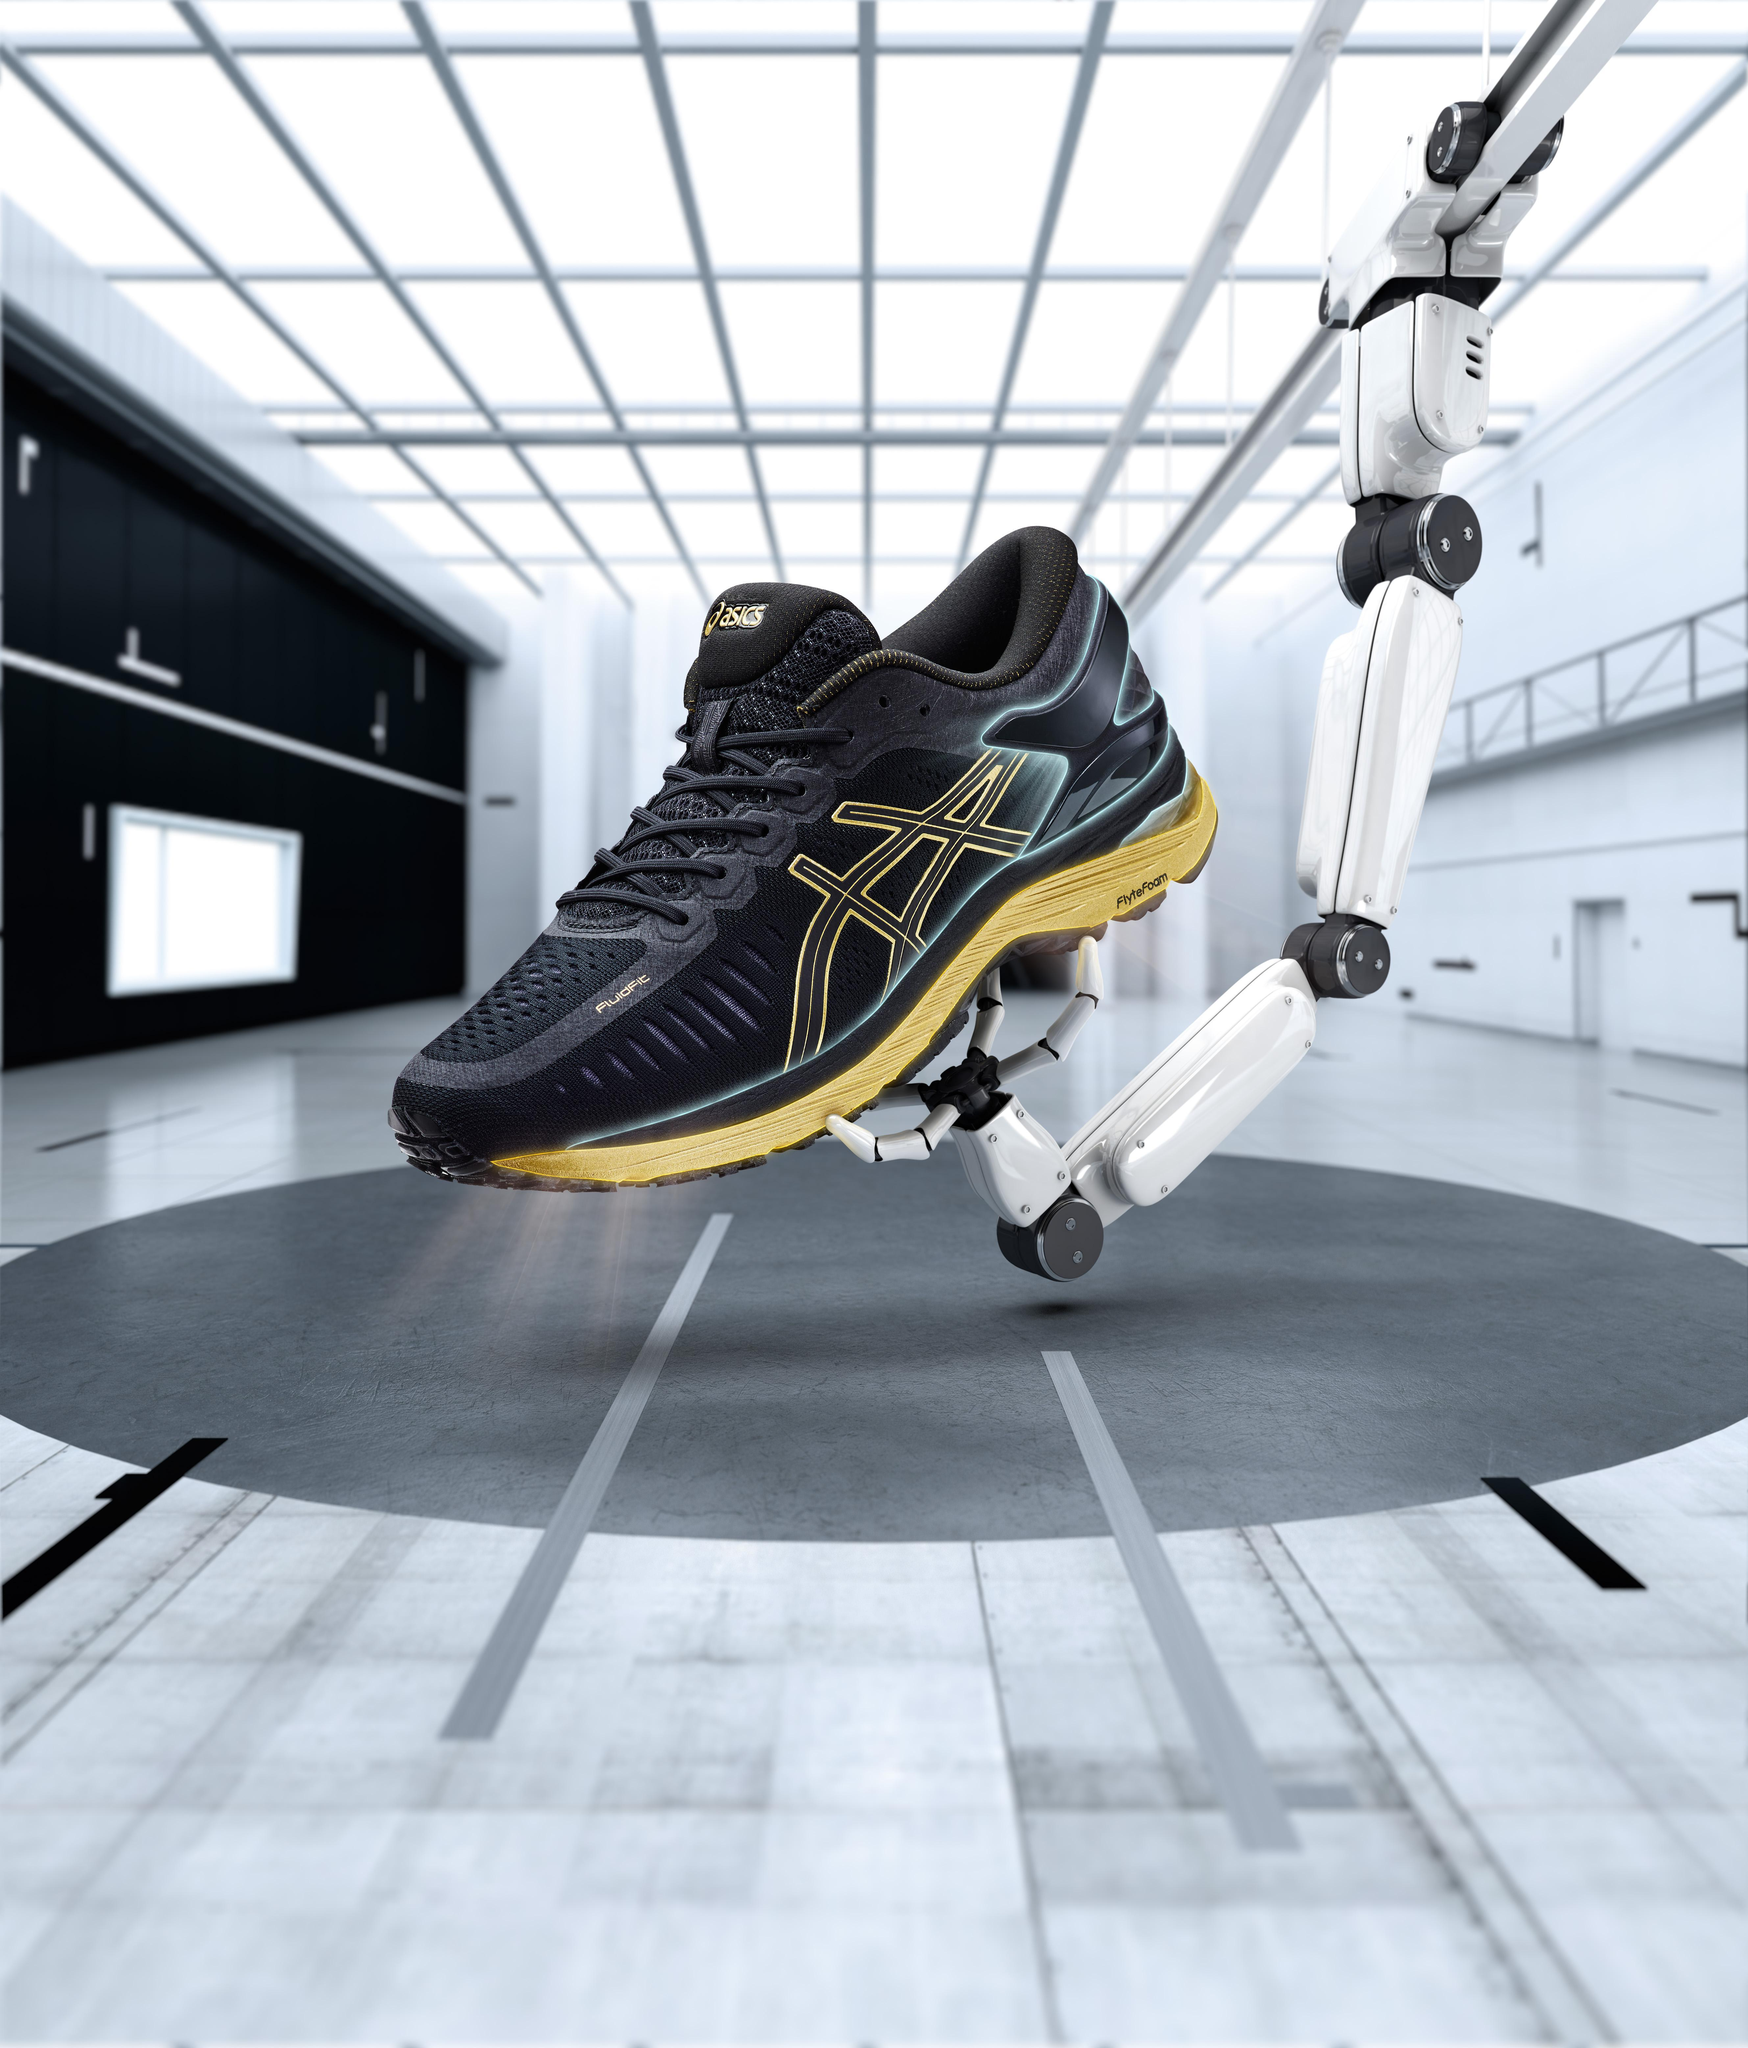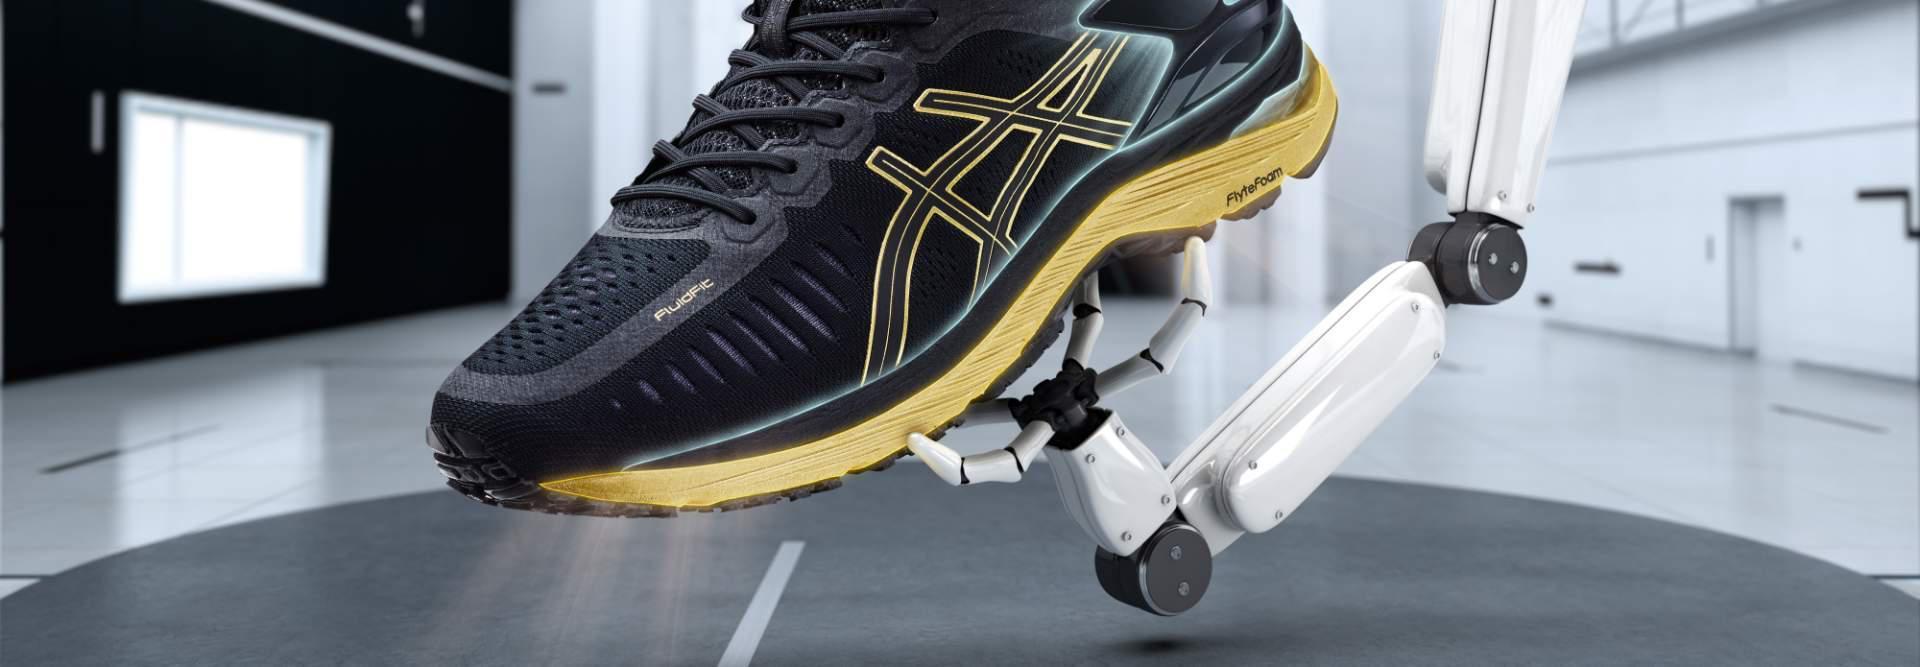The first image is the image on the left, the second image is the image on the right. Considering the images on both sides, is "There is a running shoe presented by a robotic arm in at least one of the images." valid? Answer yes or no. Yes. 